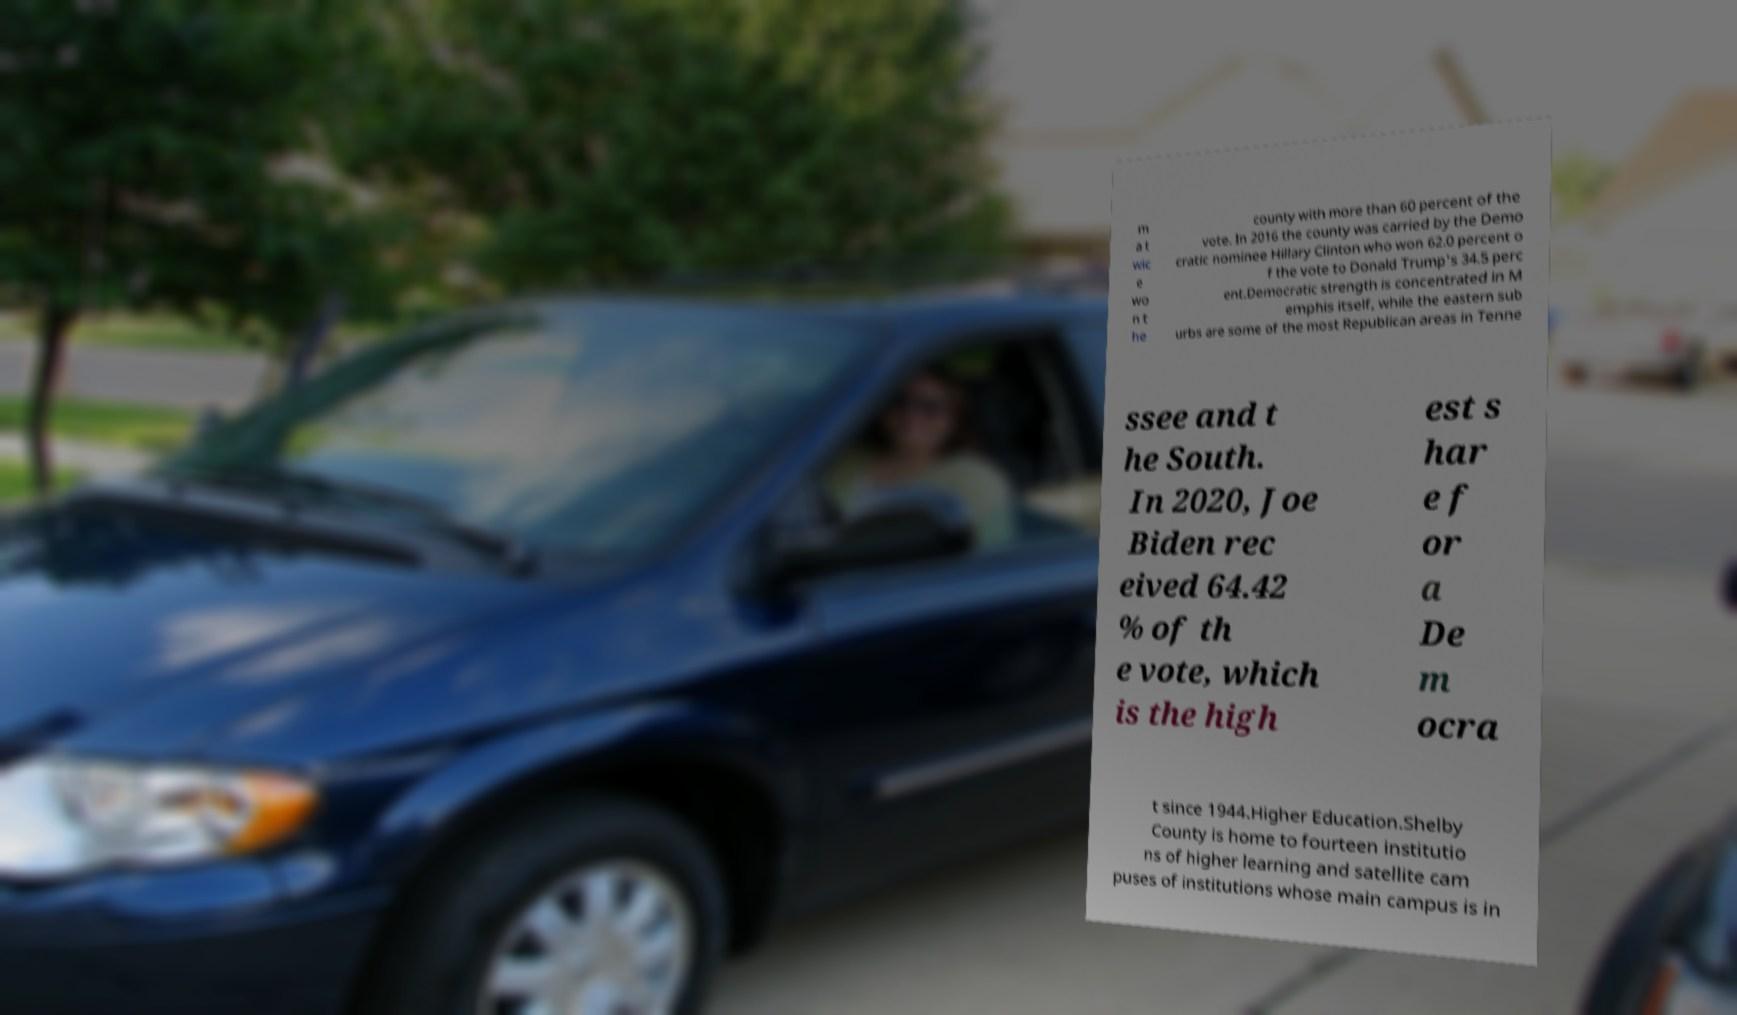There's text embedded in this image that I need extracted. Can you transcribe it verbatim? m a t wic e wo n t he county with more than 60 percent of the vote. In 2016 the county was carried by the Demo cratic nominee Hillary Clinton who won 62.0 percent o f the vote to Donald Trump's 34.5 perc ent.Democratic strength is concentrated in M emphis itself, while the eastern sub urbs are some of the most Republican areas in Tenne ssee and t he South. In 2020, Joe Biden rec eived 64.42 % of th e vote, which is the high est s har e f or a De m ocra t since 1944.Higher Education.Shelby County is home to fourteen institutio ns of higher learning and satellite cam puses of institutions whose main campus is in 